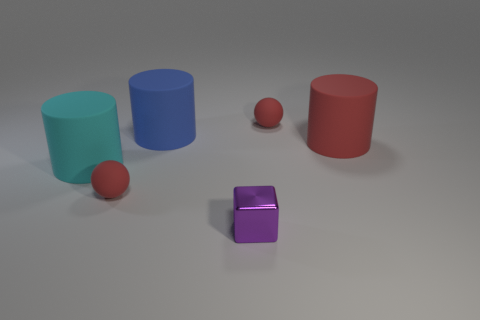Add 4 tiny cyan blocks. How many objects exist? 10 Subtract all cubes. How many objects are left? 5 Add 2 tiny red rubber spheres. How many tiny red rubber spheres exist? 4 Subtract 0 cyan blocks. How many objects are left? 6 Subtract all purple objects. Subtract all red rubber cylinders. How many objects are left? 4 Add 1 large rubber objects. How many large rubber objects are left? 4 